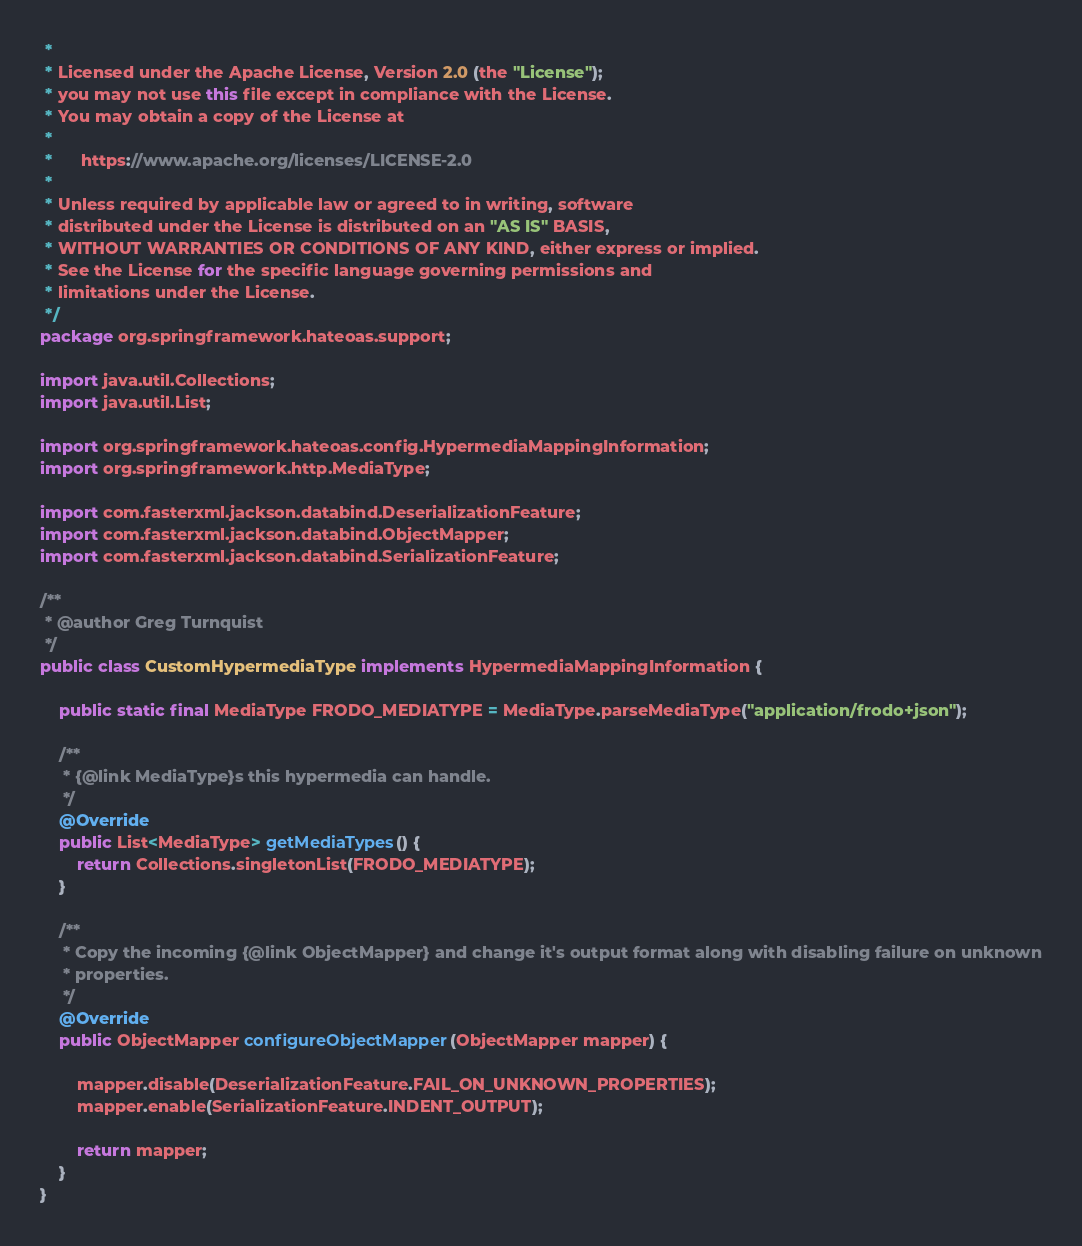Convert code to text. <code><loc_0><loc_0><loc_500><loc_500><_Java_> *
 * Licensed under the Apache License, Version 2.0 (the "License");
 * you may not use this file except in compliance with the License.
 * You may obtain a copy of the License at
 *
 *      https://www.apache.org/licenses/LICENSE-2.0
 *
 * Unless required by applicable law or agreed to in writing, software
 * distributed under the License is distributed on an "AS IS" BASIS,
 * WITHOUT WARRANTIES OR CONDITIONS OF ANY KIND, either express or implied.
 * See the License for the specific language governing permissions and
 * limitations under the License.
 */
package org.springframework.hateoas.support;

import java.util.Collections;
import java.util.List;

import org.springframework.hateoas.config.HypermediaMappingInformation;
import org.springframework.http.MediaType;

import com.fasterxml.jackson.databind.DeserializationFeature;
import com.fasterxml.jackson.databind.ObjectMapper;
import com.fasterxml.jackson.databind.SerializationFeature;

/**
 * @author Greg Turnquist
 */
public class CustomHypermediaType implements HypermediaMappingInformation {

	public static final MediaType FRODO_MEDIATYPE = MediaType.parseMediaType("application/frodo+json");

	/**
	 * {@link MediaType}s this hypermedia can handle.
	 */
	@Override
	public List<MediaType> getMediaTypes() {
		return Collections.singletonList(FRODO_MEDIATYPE);
	}

	/**
	 * Copy the incoming {@link ObjectMapper} and change it's output format along with disabling failure on unknown
	 * properties.
	 */
	@Override
	public ObjectMapper configureObjectMapper(ObjectMapper mapper) {

		mapper.disable(DeserializationFeature.FAIL_ON_UNKNOWN_PROPERTIES);
		mapper.enable(SerializationFeature.INDENT_OUTPUT);

		return mapper;
	}
}
</code> 